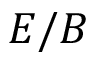Convert formula to latex. <formula><loc_0><loc_0><loc_500><loc_500>E / B</formula> 